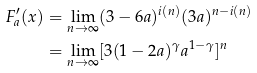Convert formula to latex. <formula><loc_0><loc_0><loc_500><loc_500>F _ { a } ^ { \prime } ( x ) & = \lim _ { n \to \infty } ( 3 - 6 a ) ^ { i ( n ) } ( 3 a ) ^ { n - i ( n ) } \\ & = \lim _ { n \to \infty } [ 3 ( 1 - 2 a ) ^ { \gamma } a ^ { 1 - \gamma } ] ^ { n }</formula> 